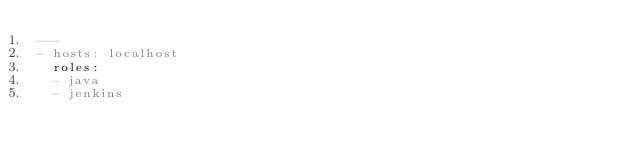<code> <loc_0><loc_0><loc_500><loc_500><_YAML_>---
- hosts: localhost
  roles:
  - java
  - jenkins
</code> 